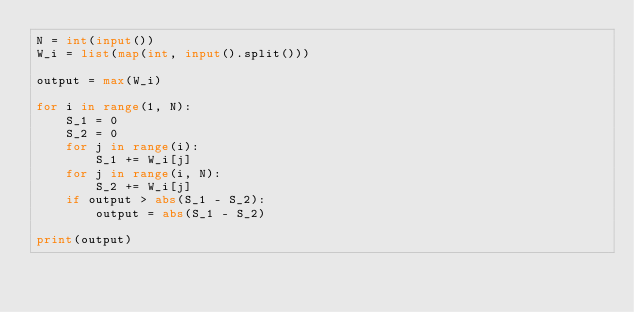<code> <loc_0><loc_0><loc_500><loc_500><_Python_>N = int(input())
W_i = list(map(int, input().split()))

output = max(W_i)

for i in range(1, N):
    S_1 = 0
    S_2 = 0
    for j in range(i):
        S_1 += W_i[j]
    for j in range(i, N):
        S_2 += W_i[j]
    if output > abs(S_1 - S_2):
        output = abs(S_1 - S_2)

print(output)
</code> 